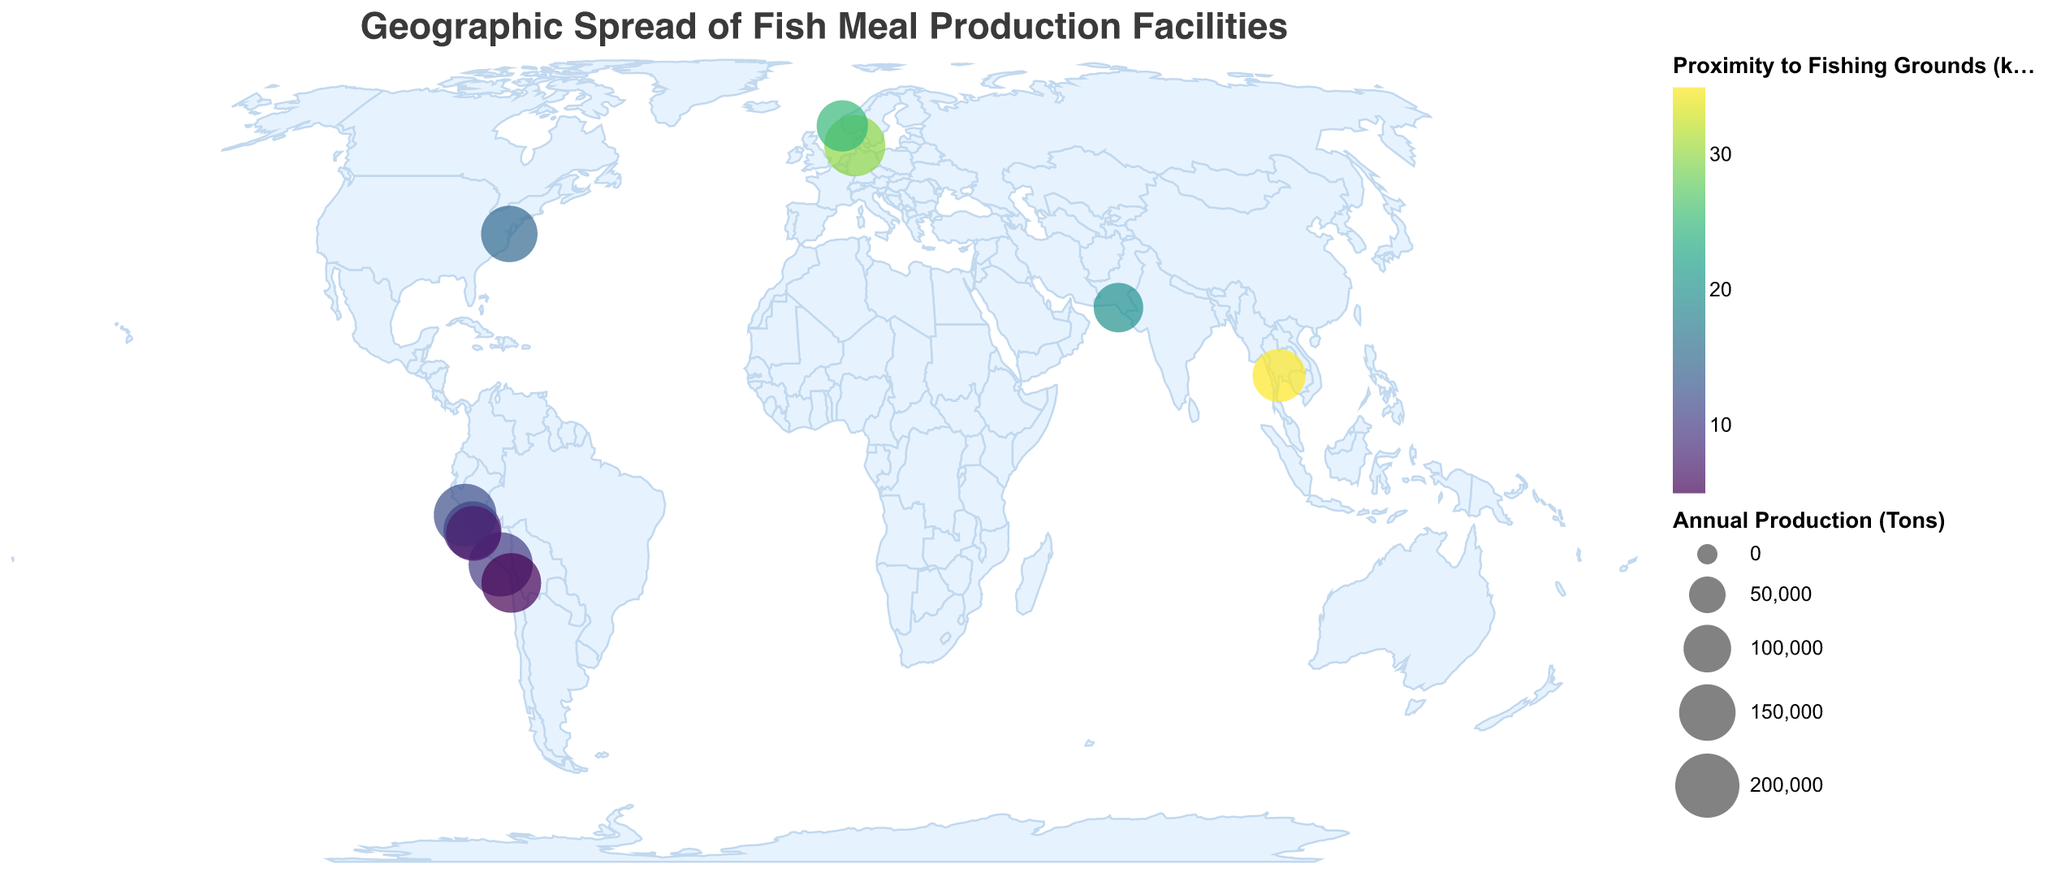How is the title of the plot displayed? The title of the plot is "Geographic Spread of Fish Meal Production Facilities" and it is placed at the top, with a font size of 18, font "Helvetica", and color "#3a3a3a".
Answer: Geographic Spread of Fish Meal Production Facilities How many fish meal production facilities are shown on the map? There are 10 fish meal production facilities displayed as circles on the map.
Answer: 10 Which facility has the largest annual production? Diamante Peru has the largest annual production, with 200,000 tons per year.
Answer: Diamante Peru Which facility is closest to its fishing grounds? Corpesca Iquique is the closest to its fishing grounds, at a distance of 5 km.
Answer: Corpesca Iquique What parameter is represented by the color of the circles on the map? The color of the circles represents "Proximity to Fishing Grounds (km)" and uses a color scale from the viridis scheme.
Answer: Proximity to Fishing Grounds (km) What parameter is represented by the size of the circles on the map? The size of the circles represents the "Annual Production (Tons)" with a size scale range from 100 to 1000.
Answer: Annual Production (Tons) Which facility has an annual production of 180,000 tons and what is its proximity to fishing grounds? TripleNine Esbjerg has an annual production of 180,000 tons and is 30 km from the fishing grounds.
Answer: TripleNine Esbjerg, 30 km Which two facilities have the shortest proximity to fishing grounds? Corpesca Iquique (5 km) and Diamante Peru (10 km) have the shortest proximity to fishing grounds.
Answer: Corpesca Iquique, Diamante Peru Which facility is furthest from its fishing grounds and how does its production compare to the other facilities? Thai Union Feedmill Samut Sakhon is furthest from its fishing grounds at 35 km. Its annual production is 130,000 tons, which is neither the highest nor the lowest among the facilities.
Answer: Thai Union Feedmill Samut Sakhon, 130,000 tons 